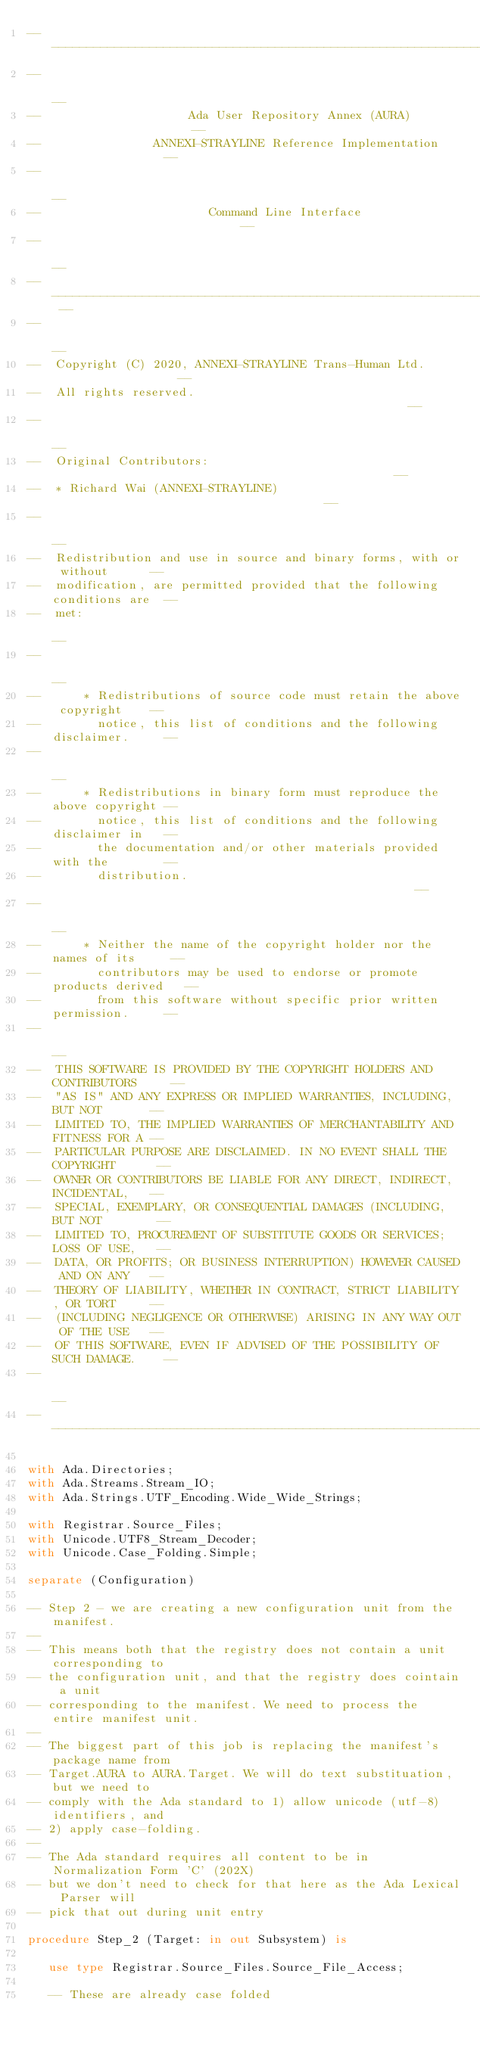<code> <loc_0><loc_0><loc_500><loc_500><_Ada_>------------------------------------------------------------------------------
--                                                                          --
--                     Ada User Repository Annex (AURA)                     --
--                ANNEXI-STRAYLINE Reference Implementation                 --
--                                                                          --
--                        Command Line Interface                            --
--                                                                          --
-- ------------------------------------------------------------------------ --
--                                                                          --
--  Copyright (C) 2020, ANNEXI-STRAYLINE Trans-Human Ltd.                   --
--  All rights reserved.                                                    --
--                                                                          --
--  Original Contributors:                                                  --
--  * Richard Wai (ANNEXI-STRAYLINE)                                        --
--                                                                          --
--  Redistribution and use in source and binary forms, with or without      --
--  modification, are permitted provided that the following conditions are  --
--  met:                                                                    --
--                                                                          --
--      * Redistributions of source code must retain the above copyright    --
--        notice, this list of conditions and the following disclaimer.     --
--                                                                          --
--      * Redistributions in binary form must reproduce the above copyright --
--        notice, this list of conditions and the following disclaimer in   --
--        the documentation and/or other materials provided with the        --
--        distribution.                                                     --
--                                                                          --
--      * Neither the name of the copyright holder nor the names of its     --
--        contributors may be used to endorse or promote products derived   --
--        from this software without specific prior written permission.     --
--                                                                          --
--  THIS SOFTWARE IS PROVIDED BY THE COPYRIGHT HOLDERS AND CONTRIBUTORS     --
--  "AS IS" AND ANY EXPRESS OR IMPLIED WARRANTIES, INCLUDING, BUT NOT       --
--  LIMITED TO, THE IMPLIED WARRANTIES OF MERCHANTABILITY AND FITNESS FOR A --
--  PARTICULAR PURPOSE ARE DISCLAIMED. IN NO EVENT SHALL THE COPYRIGHT      --
--  OWNER OR CONTRIBUTORS BE LIABLE FOR ANY DIRECT, INDIRECT, INCIDENTAL,   --
--  SPECIAL, EXEMPLARY, OR CONSEQUENTIAL DAMAGES (INCLUDING, BUT NOT        --
--  LIMITED TO, PROCUREMENT OF SUBSTITUTE GOODS OR SERVICES; LOSS OF USE,   --
--  DATA, OR PROFITS; OR BUSINESS INTERRUPTION) HOWEVER CAUSED AND ON ANY   --
--  THEORY OF LIABILITY, WHETHER IN CONTRACT, STRICT LIABILITY, OR TORT     --
--  (INCLUDING NEGLIGENCE OR OTHERWISE) ARISING IN ANY WAY OUT OF THE USE   --
--  OF THIS SOFTWARE, EVEN IF ADVISED OF THE POSSIBILITY OF SUCH DAMAGE.    --
--                                                                          --
------------------------------------------------------------------------------

with Ada.Directories;
with Ada.Streams.Stream_IO;
with Ada.Strings.UTF_Encoding.Wide_Wide_Strings;

with Registrar.Source_Files;
with Unicode.UTF8_Stream_Decoder;
with Unicode.Case_Folding.Simple;

separate (Configuration)

-- Step 2 - we are creating a new configuration unit from the manifest.
--
-- This means both that the registry does not contain a unit corresponding to
-- the configuration unit, and that the registry does cointain a unit
-- corresponding to the manifest. We need to process the entire manifest unit.
--
-- The biggest part of this job is replacing the manifest's package name from
-- Target.AURA to AURA.Target. We will do text substituation, but we need to
-- comply with the Ada standard to 1) allow unicode (utf-8) identifiers, and
-- 2) apply case-folding.
--
-- The Ada standard requires all content to be in Normalization Form 'C' (202X)
-- but we don't need to check for that here as the Ada Lexical Parser will
-- pick that out during unit entry

procedure Step_2 (Target: in out Subsystem) is
   
   use type Registrar.Source_Files.Source_File_Access;
   
   -- These are already case folded
   </code> 